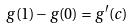Convert formula to latex. <formula><loc_0><loc_0><loc_500><loc_500>g ( 1 ) - g ( 0 ) = g ^ { \prime } ( c )</formula> 